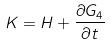Convert formula to latex. <formula><loc_0><loc_0><loc_500><loc_500>K = H + \frac { \partial G _ { 4 } } { \partial t }</formula> 